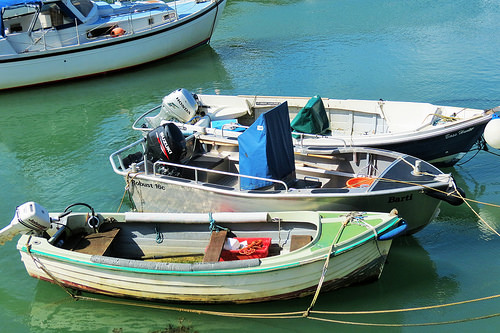<image>
Is there a boat to the left of the boat? No. The boat is not to the left of the boat. From this viewpoint, they have a different horizontal relationship. 